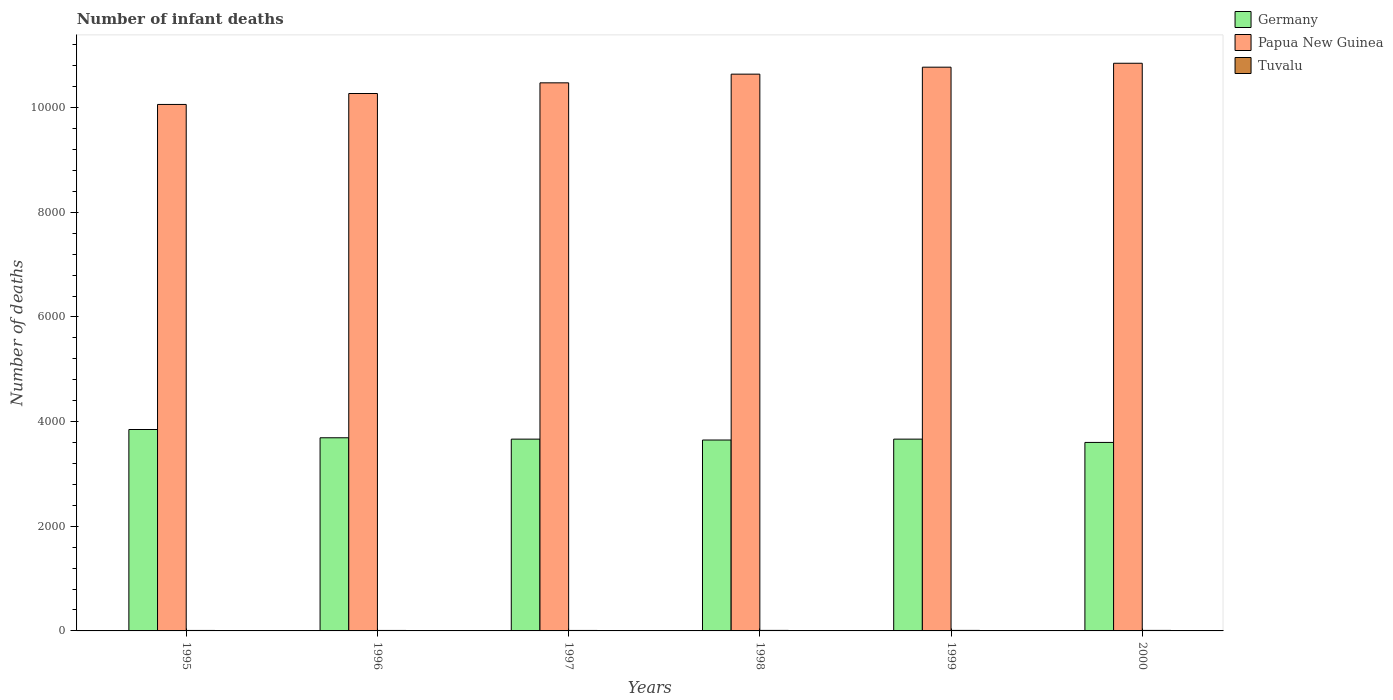How many different coloured bars are there?
Offer a very short reply. 3. How many groups of bars are there?
Your response must be concise. 6. Are the number of bars per tick equal to the number of legend labels?
Your answer should be compact. Yes. How many bars are there on the 3rd tick from the left?
Your response must be concise. 3. What is the label of the 1st group of bars from the left?
Keep it short and to the point. 1995. In how many cases, is the number of bars for a given year not equal to the number of legend labels?
Your answer should be very brief. 0. What is the number of infant deaths in Papua New Guinea in 1995?
Offer a very short reply. 1.01e+04. Across all years, what is the minimum number of infant deaths in Papua New Guinea?
Keep it short and to the point. 1.01e+04. In which year was the number of infant deaths in Tuvalu minimum?
Ensure brevity in your answer.  1995. What is the total number of infant deaths in Tuvalu in the graph?
Ensure brevity in your answer.  57. What is the difference between the number of infant deaths in Papua New Guinea in 1998 and that in 1999?
Offer a very short reply. -133. What is the difference between the number of infant deaths in Tuvalu in 2000 and the number of infant deaths in Papua New Guinea in 1995?
Give a very brief answer. -1.01e+04. What is the average number of infant deaths in Papua New Guinea per year?
Your answer should be very brief. 1.05e+04. In the year 1998, what is the difference between the number of infant deaths in Tuvalu and number of infant deaths in Germany?
Ensure brevity in your answer.  -3638. In how many years, is the number of infant deaths in Papua New Guinea greater than 8400?
Ensure brevity in your answer.  6. What is the ratio of the number of infant deaths in Tuvalu in 1996 to that in 2000?
Keep it short and to the point. 0.9. Is the difference between the number of infant deaths in Tuvalu in 1997 and 1998 greater than the difference between the number of infant deaths in Germany in 1997 and 1998?
Provide a short and direct response. No. In how many years, is the number of infant deaths in Germany greater than the average number of infant deaths in Germany taken over all years?
Make the answer very short. 2. Is the sum of the number of infant deaths in Papua New Guinea in 1996 and 1998 greater than the maximum number of infant deaths in Germany across all years?
Give a very brief answer. Yes. What does the 3rd bar from the left in 2000 represents?
Your answer should be very brief. Tuvalu. What does the 2nd bar from the right in 1996 represents?
Ensure brevity in your answer.  Papua New Guinea. Is it the case that in every year, the sum of the number of infant deaths in Papua New Guinea and number of infant deaths in Germany is greater than the number of infant deaths in Tuvalu?
Keep it short and to the point. Yes. How many years are there in the graph?
Offer a very short reply. 6. What is the difference between two consecutive major ticks on the Y-axis?
Offer a very short reply. 2000. Are the values on the major ticks of Y-axis written in scientific E-notation?
Ensure brevity in your answer.  No. Does the graph contain any zero values?
Offer a very short reply. No. Does the graph contain grids?
Provide a succinct answer. No. Where does the legend appear in the graph?
Ensure brevity in your answer.  Top right. How many legend labels are there?
Make the answer very short. 3. What is the title of the graph?
Make the answer very short. Number of infant deaths. What is the label or title of the Y-axis?
Offer a very short reply. Number of deaths. What is the Number of deaths of Germany in 1995?
Your answer should be very brief. 3849. What is the Number of deaths of Papua New Guinea in 1995?
Offer a very short reply. 1.01e+04. What is the Number of deaths of Tuvalu in 1995?
Your answer should be compact. 9. What is the Number of deaths in Germany in 1996?
Ensure brevity in your answer.  3691. What is the Number of deaths of Papua New Guinea in 1996?
Provide a short and direct response. 1.03e+04. What is the Number of deaths of Germany in 1997?
Your answer should be very brief. 3665. What is the Number of deaths of Papua New Guinea in 1997?
Your response must be concise. 1.05e+04. What is the Number of deaths in Germany in 1998?
Ensure brevity in your answer.  3648. What is the Number of deaths of Papua New Guinea in 1998?
Keep it short and to the point. 1.06e+04. What is the Number of deaths of Germany in 1999?
Your answer should be compact. 3665. What is the Number of deaths in Papua New Guinea in 1999?
Your answer should be very brief. 1.08e+04. What is the Number of deaths in Germany in 2000?
Provide a short and direct response. 3602. What is the Number of deaths of Papua New Guinea in 2000?
Your answer should be very brief. 1.08e+04. What is the Number of deaths of Tuvalu in 2000?
Ensure brevity in your answer.  10. Across all years, what is the maximum Number of deaths in Germany?
Provide a succinct answer. 3849. Across all years, what is the maximum Number of deaths in Papua New Guinea?
Your answer should be very brief. 1.08e+04. Across all years, what is the maximum Number of deaths of Tuvalu?
Ensure brevity in your answer.  10. Across all years, what is the minimum Number of deaths of Germany?
Ensure brevity in your answer.  3602. Across all years, what is the minimum Number of deaths in Papua New Guinea?
Keep it short and to the point. 1.01e+04. What is the total Number of deaths in Germany in the graph?
Give a very brief answer. 2.21e+04. What is the total Number of deaths in Papua New Guinea in the graph?
Make the answer very short. 6.31e+04. What is the difference between the Number of deaths in Germany in 1995 and that in 1996?
Provide a succinct answer. 158. What is the difference between the Number of deaths of Papua New Guinea in 1995 and that in 1996?
Your answer should be compact. -209. What is the difference between the Number of deaths in Tuvalu in 1995 and that in 1996?
Ensure brevity in your answer.  0. What is the difference between the Number of deaths of Germany in 1995 and that in 1997?
Offer a very short reply. 184. What is the difference between the Number of deaths in Papua New Guinea in 1995 and that in 1997?
Give a very brief answer. -413. What is the difference between the Number of deaths of Germany in 1995 and that in 1998?
Offer a terse response. 201. What is the difference between the Number of deaths in Papua New Guinea in 1995 and that in 1998?
Your answer should be compact. -579. What is the difference between the Number of deaths in Tuvalu in 1995 and that in 1998?
Your answer should be compact. -1. What is the difference between the Number of deaths in Germany in 1995 and that in 1999?
Your answer should be very brief. 184. What is the difference between the Number of deaths in Papua New Guinea in 1995 and that in 1999?
Provide a succinct answer. -712. What is the difference between the Number of deaths in Tuvalu in 1995 and that in 1999?
Provide a succinct answer. -1. What is the difference between the Number of deaths of Germany in 1995 and that in 2000?
Provide a succinct answer. 247. What is the difference between the Number of deaths of Papua New Guinea in 1995 and that in 2000?
Provide a short and direct response. -787. What is the difference between the Number of deaths in Tuvalu in 1995 and that in 2000?
Make the answer very short. -1. What is the difference between the Number of deaths in Papua New Guinea in 1996 and that in 1997?
Give a very brief answer. -204. What is the difference between the Number of deaths of Tuvalu in 1996 and that in 1997?
Your answer should be compact. 0. What is the difference between the Number of deaths of Germany in 1996 and that in 1998?
Ensure brevity in your answer.  43. What is the difference between the Number of deaths in Papua New Guinea in 1996 and that in 1998?
Provide a succinct answer. -370. What is the difference between the Number of deaths of Tuvalu in 1996 and that in 1998?
Provide a succinct answer. -1. What is the difference between the Number of deaths of Germany in 1996 and that in 1999?
Make the answer very short. 26. What is the difference between the Number of deaths in Papua New Guinea in 1996 and that in 1999?
Provide a short and direct response. -503. What is the difference between the Number of deaths of Germany in 1996 and that in 2000?
Your answer should be very brief. 89. What is the difference between the Number of deaths of Papua New Guinea in 1996 and that in 2000?
Ensure brevity in your answer.  -578. What is the difference between the Number of deaths in Papua New Guinea in 1997 and that in 1998?
Give a very brief answer. -166. What is the difference between the Number of deaths of Papua New Guinea in 1997 and that in 1999?
Keep it short and to the point. -299. What is the difference between the Number of deaths in Germany in 1997 and that in 2000?
Provide a succinct answer. 63. What is the difference between the Number of deaths of Papua New Guinea in 1997 and that in 2000?
Give a very brief answer. -374. What is the difference between the Number of deaths in Papua New Guinea in 1998 and that in 1999?
Ensure brevity in your answer.  -133. What is the difference between the Number of deaths of Tuvalu in 1998 and that in 1999?
Your answer should be compact. 0. What is the difference between the Number of deaths of Papua New Guinea in 1998 and that in 2000?
Provide a short and direct response. -208. What is the difference between the Number of deaths of Tuvalu in 1998 and that in 2000?
Give a very brief answer. 0. What is the difference between the Number of deaths of Germany in 1999 and that in 2000?
Ensure brevity in your answer.  63. What is the difference between the Number of deaths in Papua New Guinea in 1999 and that in 2000?
Give a very brief answer. -75. What is the difference between the Number of deaths of Germany in 1995 and the Number of deaths of Papua New Guinea in 1996?
Your response must be concise. -6421. What is the difference between the Number of deaths of Germany in 1995 and the Number of deaths of Tuvalu in 1996?
Give a very brief answer. 3840. What is the difference between the Number of deaths in Papua New Guinea in 1995 and the Number of deaths in Tuvalu in 1996?
Provide a short and direct response. 1.01e+04. What is the difference between the Number of deaths of Germany in 1995 and the Number of deaths of Papua New Guinea in 1997?
Give a very brief answer. -6625. What is the difference between the Number of deaths in Germany in 1995 and the Number of deaths in Tuvalu in 1997?
Offer a very short reply. 3840. What is the difference between the Number of deaths of Papua New Guinea in 1995 and the Number of deaths of Tuvalu in 1997?
Your answer should be very brief. 1.01e+04. What is the difference between the Number of deaths of Germany in 1995 and the Number of deaths of Papua New Guinea in 1998?
Keep it short and to the point. -6791. What is the difference between the Number of deaths of Germany in 1995 and the Number of deaths of Tuvalu in 1998?
Make the answer very short. 3839. What is the difference between the Number of deaths in Papua New Guinea in 1995 and the Number of deaths in Tuvalu in 1998?
Give a very brief answer. 1.01e+04. What is the difference between the Number of deaths in Germany in 1995 and the Number of deaths in Papua New Guinea in 1999?
Provide a succinct answer. -6924. What is the difference between the Number of deaths of Germany in 1995 and the Number of deaths of Tuvalu in 1999?
Provide a short and direct response. 3839. What is the difference between the Number of deaths in Papua New Guinea in 1995 and the Number of deaths in Tuvalu in 1999?
Offer a very short reply. 1.01e+04. What is the difference between the Number of deaths of Germany in 1995 and the Number of deaths of Papua New Guinea in 2000?
Ensure brevity in your answer.  -6999. What is the difference between the Number of deaths of Germany in 1995 and the Number of deaths of Tuvalu in 2000?
Your response must be concise. 3839. What is the difference between the Number of deaths in Papua New Guinea in 1995 and the Number of deaths in Tuvalu in 2000?
Your answer should be very brief. 1.01e+04. What is the difference between the Number of deaths of Germany in 1996 and the Number of deaths of Papua New Guinea in 1997?
Keep it short and to the point. -6783. What is the difference between the Number of deaths of Germany in 1996 and the Number of deaths of Tuvalu in 1997?
Make the answer very short. 3682. What is the difference between the Number of deaths in Papua New Guinea in 1996 and the Number of deaths in Tuvalu in 1997?
Make the answer very short. 1.03e+04. What is the difference between the Number of deaths in Germany in 1996 and the Number of deaths in Papua New Guinea in 1998?
Give a very brief answer. -6949. What is the difference between the Number of deaths in Germany in 1996 and the Number of deaths in Tuvalu in 1998?
Keep it short and to the point. 3681. What is the difference between the Number of deaths in Papua New Guinea in 1996 and the Number of deaths in Tuvalu in 1998?
Provide a succinct answer. 1.03e+04. What is the difference between the Number of deaths in Germany in 1996 and the Number of deaths in Papua New Guinea in 1999?
Provide a succinct answer. -7082. What is the difference between the Number of deaths in Germany in 1996 and the Number of deaths in Tuvalu in 1999?
Give a very brief answer. 3681. What is the difference between the Number of deaths in Papua New Guinea in 1996 and the Number of deaths in Tuvalu in 1999?
Keep it short and to the point. 1.03e+04. What is the difference between the Number of deaths in Germany in 1996 and the Number of deaths in Papua New Guinea in 2000?
Provide a succinct answer. -7157. What is the difference between the Number of deaths of Germany in 1996 and the Number of deaths of Tuvalu in 2000?
Make the answer very short. 3681. What is the difference between the Number of deaths of Papua New Guinea in 1996 and the Number of deaths of Tuvalu in 2000?
Provide a short and direct response. 1.03e+04. What is the difference between the Number of deaths of Germany in 1997 and the Number of deaths of Papua New Guinea in 1998?
Your answer should be compact. -6975. What is the difference between the Number of deaths in Germany in 1997 and the Number of deaths in Tuvalu in 1998?
Your answer should be compact. 3655. What is the difference between the Number of deaths in Papua New Guinea in 1997 and the Number of deaths in Tuvalu in 1998?
Make the answer very short. 1.05e+04. What is the difference between the Number of deaths in Germany in 1997 and the Number of deaths in Papua New Guinea in 1999?
Offer a very short reply. -7108. What is the difference between the Number of deaths in Germany in 1997 and the Number of deaths in Tuvalu in 1999?
Make the answer very short. 3655. What is the difference between the Number of deaths of Papua New Guinea in 1997 and the Number of deaths of Tuvalu in 1999?
Your response must be concise. 1.05e+04. What is the difference between the Number of deaths in Germany in 1997 and the Number of deaths in Papua New Guinea in 2000?
Your answer should be very brief. -7183. What is the difference between the Number of deaths in Germany in 1997 and the Number of deaths in Tuvalu in 2000?
Your response must be concise. 3655. What is the difference between the Number of deaths of Papua New Guinea in 1997 and the Number of deaths of Tuvalu in 2000?
Provide a short and direct response. 1.05e+04. What is the difference between the Number of deaths of Germany in 1998 and the Number of deaths of Papua New Guinea in 1999?
Make the answer very short. -7125. What is the difference between the Number of deaths of Germany in 1998 and the Number of deaths of Tuvalu in 1999?
Your answer should be compact. 3638. What is the difference between the Number of deaths in Papua New Guinea in 1998 and the Number of deaths in Tuvalu in 1999?
Give a very brief answer. 1.06e+04. What is the difference between the Number of deaths in Germany in 1998 and the Number of deaths in Papua New Guinea in 2000?
Your answer should be very brief. -7200. What is the difference between the Number of deaths in Germany in 1998 and the Number of deaths in Tuvalu in 2000?
Offer a very short reply. 3638. What is the difference between the Number of deaths in Papua New Guinea in 1998 and the Number of deaths in Tuvalu in 2000?
Ensure brevity in your answer.  1.06e+04. What is the difference between the Number of deaths in Germany in 1999 and the Number of deaths in Papua New Guinea in 2000?
Your answer should be compact. -7183. What is the difference between the Number of deaths in Germany in 1999 and the Number of deaths in Tuvalu in 2000?
Provide a short and direct response. 3655. What is the difference between the Number of deaths in Papua New Guinea in 1999 and the Number of deaths in Tuvalu in 2000?
Your response must be concise. 1.08e+04. What is the average Number of deaths in Germany per year?
Your response must be concise. 3686.67. What is the average Number of deaths of Papua New Guinea per year?
Offer a very short reply. 1.05e+04. In the year 1995, what is the difference between the Number of deaths in Germany and Number of deaths in Papua New Guinea?
Provide a succinct answer. -6212. In the year 1995, what is the difference between the Number of deaths in Germany and Number of deaths in Tuvalu?
Offer a terse response. 3840. In the year 1995, what is the difference between the Number of deaths of Papua New Guinea and Number of deaths of Tuvalu?
Keep it short and to the point. 1.01e+04. In the year 1996, what is the difference between the Number of deaths of Germany and Number of deaths of Papua New Guinea?
Offer a terse response. -6579. In the year 1996, what is the difference between the Number of deaths of Germany and Number of deaths of Tuvalu?
Give a very brief answer. 3682. In the year 1996, what is the difference between the Number of deaths of Papua New Guinea and Number of deaths of Tuvalu?
Offer a terse response. 1.03e+04. In the year 1997, what is the difference between the Number of deaths in Germany and Number of deaths in Papua New Guinea?
Provide a short and direct response. -6809. In the year 1997, what is the difference between the Number of deaths of Germany and Number of deaths of Tuvalu?
Your answer should be compact. 3656. In the year 1997, what is the difference between the Number of deaths in Papua New Guinea and Number of deaths in Tuvalu?
Offer a very short reply. 1.05e+04. In the year 1998, what is the difference between the Number of deaths in Germany and Number of deaths in Papua New Guinea?
Provide a succinct answer. -6992. In the year 1998, what is the difference between the Number of deaths of Germany and Number of deaths of Tuvalu?
Make the answer very short. 3638. In the year 1998, what is the difference between the Number of deaths of Papua New Guinea and Number of deaths of Tuvalu?
Provide a short and direct response. 1.06e+04. In the year 1999, what is the difference between the Number of deaths in Germany and Number of deaths in Papua New Guinea?
Offer a terse response. -7108. In the year 1999, what is the difference between the Number of deaths in Germany and Number of deaths in Tuvalu?
Ensure brevity in your answer.  3655. In the year 1999, what is the difference between the Number of deaths of Papua New Guinea and Number of deaths of Tuvalu?
Provide a succinct answer. 1.08e+04. In the year 2000, what is the difference between the Number of deaths of Germany and Number of deaths of Papua New Guinea?
Make the answer very short. -7246. In the year 2000, what is the difference between the Number of deaths of Germany and Number of deaths of Tuvalu?
Your answer should be very brief. 3592. In the year 2000, what is the difference between the Number of deaths of Papua New Guinea and Number of deaths of Tuvalu?
Offer a very short reply. 1.08e+04. What is the ratio of the Number of deaths in Germany in 1995 to that in 1996?
Give a very brief answer. 1.04. What is the ratio of the Number of deaths in Papua New Guinea in 1995 to that in 1996?
Provide a succinct answer. 0.98. What is the ratio of the Number of deaths of Tuvalu in 1995 to that in 1996?
Keep it short and to the point. 1. What is the ratio of the Number of deaths of Germany in 1995 to that in 1997?
Provide a succinct answer. 1.05. What is the ratio of the Number of deaths in Papua New Guinea in 1995 to that in 1997?
Offer a terse response. 0.96. What is the ratio of the Number of deaths of Tuvalu in 1995 to that in 1997?
Keep it short and to the point. 1. What is the ratio of the Number of deaths in Germany in 1995 to that in 1998?
Keep it short and to the point. 1.06. What is the ratio of the Number of deaths in Papua New Guinea in 1995 to that in 1998?
Give a very brief answer. 0.95. What is the ratio of the Number of deaths of Germany in 1995 to that in 1999?
Your response must be concise. 1.05. What is the ratio of the Number of deaths of Papua New Guinea in 1995 to that in 1999?
Your answer should be compact. 0.93. What is the ratio of the Number of deaths of Germany in 1995 to that in 2000?
Make the answer very short. 1.07. What is the ratio of the Number of deaths of Papua New Guinea in 1995 to that in 2000?
Your response must be concise. 0.93. What is the ratio of the Number of deaths in Tuvalu in 1995 to that in 2000?
Offer a terse response. 0.9. What is the ratio of the Number of deaths in Germany in 1996 to that in 1997?
Your answer should be very brief. 1.01. What is the ratio of the Number of deaths of Papua New Guinea in 1996 to that in 1997?
Provide a succinct answer. 0.98. What is the ratio of the Number of deaths in Tuvalu in 1996 to that in 1997?
Give a very brief answer. 1. What is the ratio of the Number of deaths of Germany in 1996 to that in 1998?
Make the answer very short. 1.01. What is the ratio of the Number of deaths in Papua New Guinea in 1996 to that in 1998?
Keep it short and to the point. 0.97. What is the ratio of the Number of deaths of Germany in 1996 to that in 1999?
Offer a very short reply. 1.01. What is the ratio of the Number of deaths in Papua New Guinea in 1996 to that in 1999?
Your response must be concise. 0.95. What is the ratio of the Number of deaths in Germany in 1996 to that in 2000?
Make the answer very short. 1.02. What is the ratio of the Number of deaths of Papua New Guinea in 1996 to that in 2000?
Ensure brevity in your answer.  0.95. What is the ratio of the Number of deaths in Tuvalu in 1996 to that in 2000?
Your answer should be compact. 0.9. What is the ratio of the Number of deaths of Germany in 1997 to that in 1998?
Your response must be concise. 1. What is the ratio of the Number of deaths of Papua New Guinea in 1997 to that in 1998?
Offer a very short reply. 0.98. What is the ratio of the Number of deaths of Tuvalu in 1997 to that in 1998?
Give a very brief answer. 0.9. What is the ratio of the Number of deaths of Papua New Guinea in 1997 to that in 1999?
Keep it short and to the point. 0.97. What is the ratio of the Number of deaths in Tuvalu in 1997 to that in 1999?
Your response must be concise. 0.9. What is the ratio of the Number of deaths of Germany in 1997 to that in 2000?
Provide a short and direct response. 1.02. What is the ratio of the Number of deaths in Papua New Guinea in 1997 to that in 2000?
Your answer should be very brief. 0.97. What is the ratio of the Number of deaths of Germany in 1998 to that in 1999?
Offer a very short reply. 1. What is the ratio of the Number of deaths in Papua New Guinea in 1998 to that in 1999?
Give a very brief answer. 0.99. What is the ratio of the Number of deaths in Tuvalu in 1998 to that in 1999?
Make the answer very short. 1. What is the ratio of the Number of deaths of Germany in 1998 to that in 2000?
Ensure brevity in your answer.  1.01. What is the ratio of the Number of deaths in Papua New Guinea in 1998 to that in 2000?
Make the answer very short. 0.98. What is the ratio of the Number of deaths of Tuvalu in 1998 to that in 2000?
Ensure brevity in your answer.  1. What is the ratio of the Number of deaths of Germany in 1999 to that in 2000?
Keep it short and to the point. 1.02. What is the ratio of the Number of deaths in Papua New Guinea in 1999 to that in 2000?
Provide a succinct answer. 0.99. What is the difference between the highest and the second highest Number of deaths in Germany?
Your answer should be compact. 158. What is the difference between the highest and the second highest Number of deaths in Papua New Guinea?
Your response must be concise. 75. What is the difference between the highest and the second highest Number of deaths of Tuvalu?
Your answer should be very brief. 0. What is the difference between the highest and the lowest Number of deaths of Germany?
Give a very brief answer. 247. What is the difference between the highest and the lowest Number of deaths of Papua New Guinea?
Provide a short and direct response. 787. 